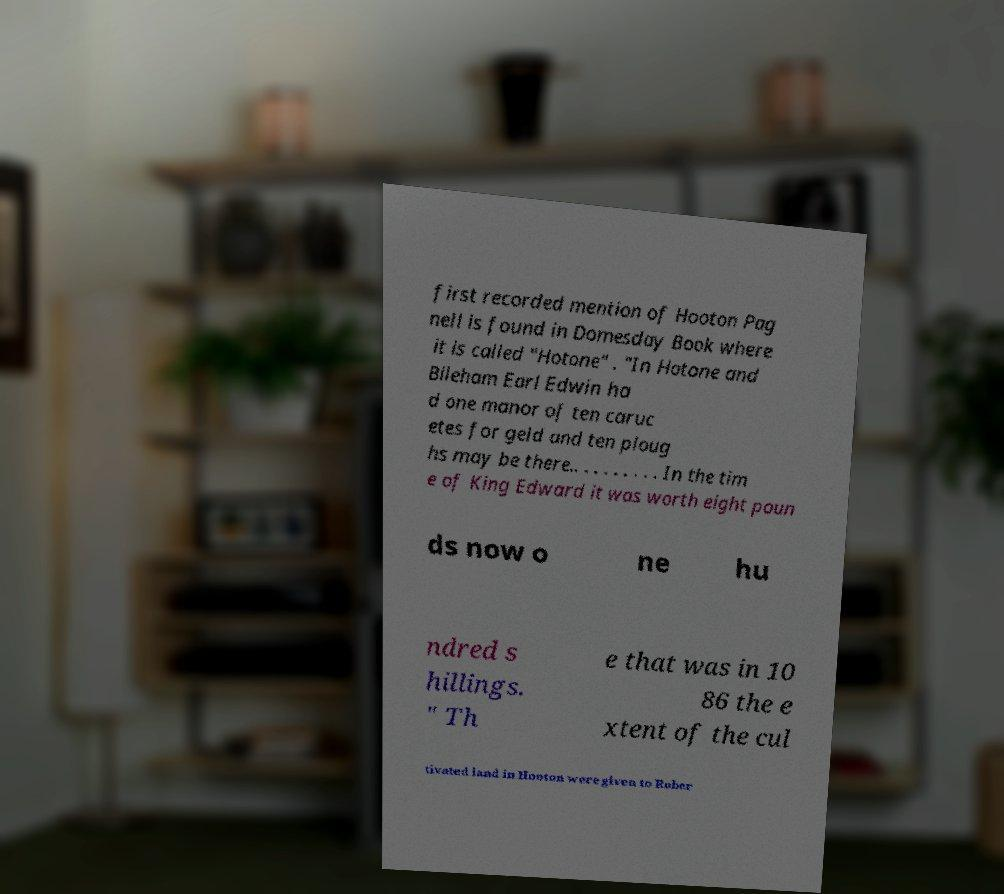Could you extract and type out the text from this image? first recorded mention of Hooton Pag nell is found in Domesday Book where it is called "Hotone" . "In Hotone and Bileham Earl Edwin ha d one manor of ten caruc etes for geld and ten ploug hs may be there.. . . . . . . . . In the tim e of King Edward it was worth eight poun ds now o ne hu ndred s hillings. " Th e that was in 10 86 the e xtent of the cul tivated land in Hooton were given to Rober 